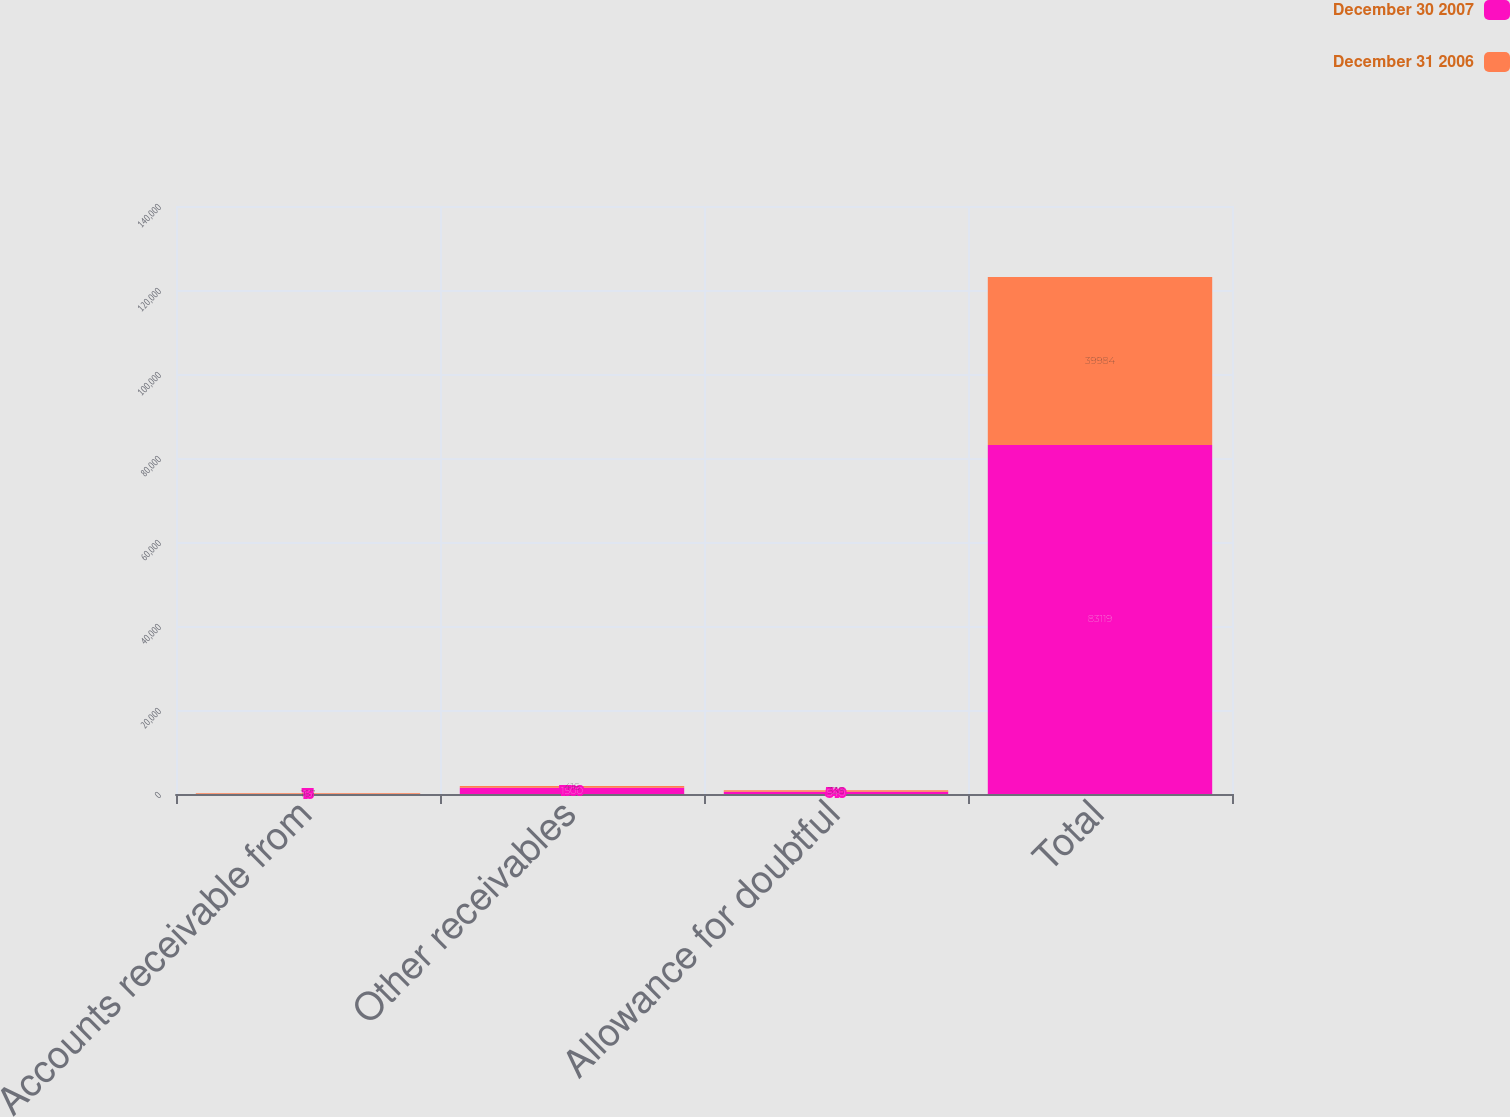<chart> <loc_0><loc_0><loc_500><loc_500><stacked_bar_chart><ecel><fcel>Accounts receivable from<fcel>Other receivables<fcel>Allowance for doubtful<fcel>Total<nl><fcel>December 30 2007<fcel>15<fcel>1500<fcel>540<fcel>83119<nl><fcel>December 31 2006<fcel>167<fcel>416<fcel>338<fcel>39984<nl></chart> 